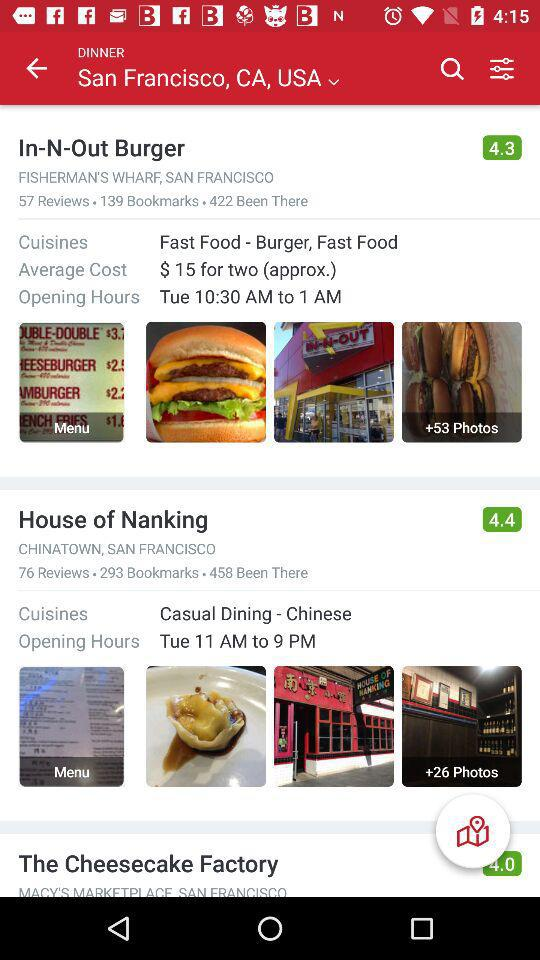How many reviews do House of Nanking have?
Answer the question using a single word or phrase. 76 